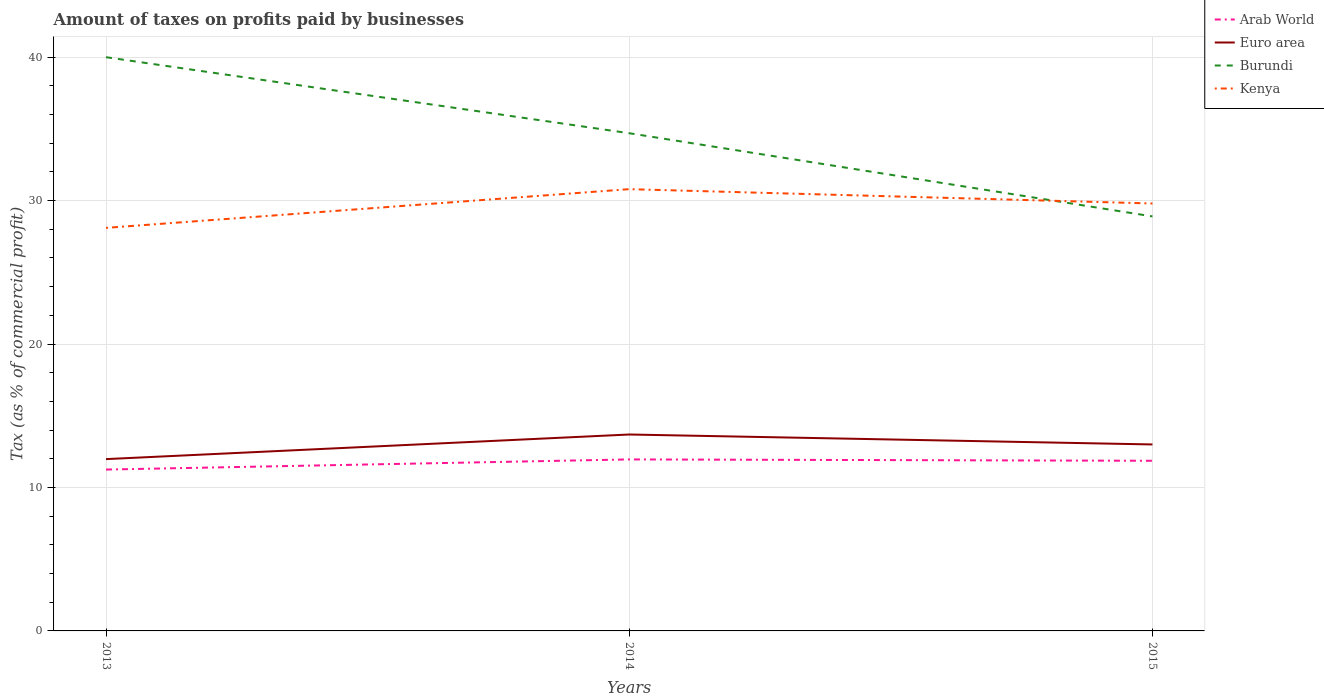Across all years, what is the maximum percentage of taxes paid by businesses in Euro area?
Provide a succinct answer. 11.98. In which year was the percentage of taxes paid by businesses in Burundi maximum?
Make the answer very short. 2015. What is the difference between the highest and the second highest percentage of taxes paid by businesses in Arab World?
Offer a very short reply. 0.71. What is the difference between the highest and the lowest percentage of taxes paid by businesses in Burundi?
Your answer should be compact. 2. How many years are there in the graph?
Offer a very short reply. 3. Are the values on the major ticks of Y-axis written in scientific E-notation?
Your answer should be compact. No. Does the graph contain any zero values?
Offer a very short reply. No. Does the graph contain grids?
Your answer should be very brief. Yes. How many legend labels are there?
Your answer should be compact. 4. How are the legend labels stacked?
Make the answer very short. Vertical. What is the title of the graph?
Make the answer very short. Amount of taxes on profits paid by businesses. Does "Small states" appear as one of the legend labels in the graph?
Provide a short and direct response. No. What is the label or title of the X-axis?
Make the answer very short. Years. What is the label or title of the Y-axis?
Your answer should be very brief. Tax (as % of commercial profit). What is the Tax (as % of commercial profit) of Arab World in 2013?
Your response must be concise. 11.25. What is the Tax (as % of commercial profit) of Euro area in 2013?
Keep it short and to the point. 11.98. What is the Tax (as % of commercial profit) of Burundi in 2013?
Ensure brevity in your answer.  40. What is the Tax (as % of commercial profit) in Kenya in 2013?
Provide a succinct answer. 28.1. What is the Tax (as % of commercial profit) of Arab World in 2014?
Ensure brevity in your answer.  11.96. What is the Tax (as % of commercial profit) in Euro area in 2014?
Provide a succinct answer. 13.69. What is the Tax (as % of commercial profit) of Burundi in 2014?
Keep it short and to the point. 34.7. What is the Tax (as % of commercial profit) in Kenya in 2014?
Give a very brief answer. 30.8. What is the Tax (as % of commercial profit) of Arab World in 2015?
Your answer should be very brief. 11.86. What is the Tax (as % of commercial profit) of Euro area in 2015?
Offer a terse response. 13. What is the Tax (as % of commercial profit) of Burundi in 2015?
Give a very brief answer. 28.9. What is the Tax (as % of commercial profit) of Kenya in 2015?
Your answer should be compact. 29.8. Across all years, what is the maximum Tax (as % of commercial profit) of Arab World?
Provide a succinct answer. 11.96. Across all years, what is the maximum Tax (as % of commercial profit) in Euro area?
Offer a terse response. 13.69. Across all years, what is the maximum Tax (as % of commercial profit) in Kenya?
Your response must be concise. 30.8. Across all years, what is the minimum Tax (as % of commercial profit) in Arab World?
Give a very brief answer. 11.25. Across all years, what is the minimum Tax (as % of commercial profit) of Euro area?
Offer a terse response. 11.98. Across all years, what is the minimum Tax (as % of commercial profit) in Burundi?
Your answer should be very brief. 28.9. Across all years, what is the minimum Tax (as % of commercial profit) in Kenya?
Offer a terse response. 28.1. What is the total Tax (as % of commercial profit) in Arab World in the graph?
Give a very brief answer. 35.07. What is the total Tax (as % of commercial profit) in Euro area in the graph?
Your response must be concise. 38.67. What is the total Tax (as % of commercial profit) of Burundi in the graph?
Keep it short and to the point. 103.6. What is the total Tax (as % of commercial profit) in Kenya in the graph?
Keep it short and to the point. 88.7. What is the difference between the Tax (as % of commercial profit) in Arab World in 2013 and that in 2014?
Offer a very short reply. -0.71. What is the difference between the Tax (as % of commercial profit) in Euro area in 2013 and that in 2014?
Offer a very short reply. -1.72. What is the difference between the Tax (as % of commercial profit) in Arab World in 2013 and that in 2015?
Offer a very short reply. -0.61. What is the difference between the Tax (as % of commercial profit) in Euro area in 2013 and that in 2015?
Give a very brief answer. -1.02. What is the difference between the Tax (as % of commercial profit) of Burundi in 2013 and that in 2015?
Give a very brief answer. 11.1. What is the difference between the Tax (as % of commercial profit) in Kenya in 2013 and that in 2015?
Give a very brief answer. -1.7. What is the difference between the Tax (as % of commercial profit) in Arab World in 2014 and that in 2015?
Your response must be concise. 0.1. What is the difference between the Tax (as % of commercial profit) in Euro area in 2014 and that in 2015?
Your answer should be compact. 0.69. What is the difference between the Tax (as % of commercial profit) of Arab World in 2013 and the Tax (as % of commercial profit) of Euro area in 2014?
Your answer should be very brief. -2.44. What is the difference between the Tax (as % of commercial profit) in Arab World in 2013 and the Tax (as % of commercial profit) in Burundi in 2014?
Provide a succinct answer. -23.45. What is the difference between the Tax (as % of commercial profit) in Arab World in 2013 and the Tax (as % of commercial profit) in Kenya in 2014?
Offer a very short reply. -19.55. What is the difference between the Tax (as % of commercial profit) of Euro area in 2013 and the Tax (as % of commercial profit) of Burundi in 2014?
Offer a very short reply. -22.72. What is the difference between the Tax (as % of commercial profit) in Euro area in 2013 and the Tax (as % of commercial profit) in Kenya in 2014?
Your response must be concise. -18.82. What is the difference between the Tax (as % of commercial profit) of Arab World in 2013 and the Tax (as % of commercial profit) of Euro area in 2015?
Your answer should be very brief. -1.75. What is the difference between the Tax (as % of commercial profit) in Arab World in 2013 and the Tax (as % of commercial profit) in Burundi in 2015?
Keep it short and to the point. -17.65. What is the difference between the Tax (as % of commercial profit) of Arab World in 2013 and the Tax (as % of commercial profit) of Kenya in 2015?
Offer a very short reply. -18.55. What is the difference between the Tax (as % of commercial profit) of Euro area in 2013 and the Tax (as % of commercial profit) of Burundi in 2015?
Keep it short and to the point. -16.92. What is the difference between the Tax (as % of commercial profit) in Euro area in 2013 and the Tax (as % of commercial profit) in Kenya in 2015?
Offer a terse response. -17.82. What is the difference between the Tax (as % of commercial profit) of Burundi in 2013 and the Tax (as % of commercial profit) of Kenya in 2015?
Provide a short and direct response. 10.2. What is the difference between the Tax (as % of commercial profit) of Arab World in 2014 and the Tax (as % of commercial profit) of Euro area in 2015?
Offer a terse response. -1.04. What is the difference between the Tax (as % of commercial profit) of Arab World in 2014 and the Tax (as % of commercial profit) of Burundi in 2015?
Your response must be concise. -16.94. What is the difference between the Tax (as % of commercial profit) of Arab World in 2014 and the Tax (as % of commercial profit) of Kenya in 2015?
Give a very brief answer. -17.84. What is the difference between the Tax (as % of commercial profit) in Euro area in 2014 and the Tax (as % of commercial profit) in Burundi in 2015?
Offer a terse response. -15.21. What is the difference between the Tax (as % of commercial profit) of Euro area in 2014 and the Tax (as % of commercial profit) of Kenya in 2015?
Keep it short and to the point. -16.11. What is the average Tax (as % of commercial profit) of Arab World per year?
Ensure brevity in your answer.  11.69. What is the average Tax (as % of commercial profit) in Euro area per year?
Provide a succinct answer. 12.89. What is the average Tax (as % of commercial profit) of Burundi per year?
Ensure brevity in your answer.  34.53. What is the average Tax (as % of commercial profit) of Kenya per year?
Provide a short and direct response. 29.57. In the year 2013, what is the difference between the Tax (as % of commercial profit) in Arab World and Tax (as % of commercial profit) in Euro area?
Provide a succinct answer. -0.73. In the year 2013, what is the difference between the Tax (as % of commercial profit) in Arab World and Tax (as % of commercial profit) in Burundi?
Provide a short and direct response. -28.75. In the year 2013, what is the difference between the Tax (as % of commercial profit) of Arab World and Tax (as % of commercial profit) of Kenya?
Provide a succinct answer. -16.85. In the year 2013, what is the difference between the Tax (as % of commercial profit) in Euro area and Tax (as % of commercial profit) in Burundi?
Offer a very short reply. -28.02. In the year 2013, what is the difference between the Tax (as % of commercial profit) of Euro area and Tax (as % of commercial profit) of Kenya?
Ensure brevity in your answer.  -16.12. In the year 2014, what is the difference between the Tax (as % of commercial profit) in Arab World and Tax (as % of commercial profit) in Euro area?
Offer a terse response. -1.74. In the year 2014, what is the difference between the Tax (as % of commercial profit) of Arab World and Tax (as % of commercial profit) of Burundi?
Provide a short and direct response. -22.74. In the year 2014, what is the difference between the Tax (as % of commercial profit) of Arab World and Tax (as % of commercial profit) of Kenya?
Give a very brief answer. -18.84. In the year 2014, what is the difference between the Tax (as % of commercial profit) in Euro area and Tax (as % of commercial profit) in Burundi?
Your answer should be compact. -21.01. In the year 2014, what is the difference between the Tax (as % of commercial profit) of Euro area and Tax (as % of commercial profit) of Kenya?
Keep it short and to the point. -17.11. In the year 2015, what is the difference between the Tax (as % of commercial profit) of Arab World and Tax (as % of commercial profit) of Euro area?
Provide a succinct answer. -1.14. In the year 2015, what is the difference between the Tax (as % of commercial profit) in Arab World and Tax (as % of commercial profit) in Burundi?
Your response must be concise. -17.04. In the year 2015, what is the difference between the Tax (as % of commercial profit) in Arab World and Tax (as % of commercial profit) in Kenya?
Your answer should be compact. -17.94. In the year 2015, what is the difference between the Tax (as % of commercial profit) in Euro area and Tax (as % of commercial profit) in Burundi?
Ensure brevity in your answer.  -15.9. In the year 2015, what is the difference between the Tax (as % of commercial profit) in Euro area and Tax (as % of commercial profit) in Kenya?
Ensure brevity in your answer.  -16.8. What is the ratio of the Tax (as % of commercial profit) of Arab World in 2013 to that in 2014?
Provide a succinct answer. 0.94. What is the ratio of the Tax (as % of commercial profit) of Euro area in 2013 to that in 2014?
Keep it short and to the point. 0.87. What is the ratio of the Tax (as % of commercial profit) of Burundi in 2013 to that in 2014?
Offer a terse response. 1.15. What is the ratio of the Tax (as % of commercial profit) of Kenya in 2013 to that in 2014?
Your response must be concise. 0.91. What is the ratio of the Tax (as % of commercial profit) of Arab World in 2013 to that in 2015?
Keep it short and to the point. 0.95. What is the ratio of the Tax (as % of commercial profit) of Euro area in 2013 to that in 2015?
Offer a terse response. 0.92. What is the ratio of the Tax (as % of commercial profit) of Burundi in 2013 to that in 2015?
Your response must be concise. 1.38. What is the ratio of the Tax (as % of commercial profit) of Kenya in 2013 to that in 2015?
Ensure brevity in your answer.  0.94. What is the ratio of the Tax (as % of commercial profit) in Arab World in 2014 to that in 2015?
Offer a very short reply. 1.01. What is the ratio of the Tax (as % of commercial profit) of Euro area in 2014 to that in 2015?
Your answer should be compact. 1.05. What is the ratio of the Tax (as % of commercial profit) of Burundi in 2014 to that in 2015?
Make the answer very short. 1.2. What is the ratio of the Tax (as % of commercial profit) of Kenya in 2014 to that in 2015?
Your response must be concise. 1.03. What is the difference between the highest and the second highest Tax (as % of commercial profit) in Arab World?
Make the answer very short. 0.1. What is the difference between the highest and the second highest Tax (as % of commercial profit) of Euro area?
Provide a short and direct response. 0.69. What is the difference between the highest and the lowest Tax (as % of commercial profit) in Arab World?
Make the answer very short. 0.71. What is the difference between the highest and the lowest Tax (as % of commercial profit) in Euro area?
Your answer should be compact. 1.72. What is the difference between the highest and the lowest Tax (as % of commercial profit) of Burundi?
Your answer should be very brief. 11.1. 